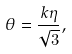<formula> <loc_0><loc_0><loc_500><loc_500>\theta = \frac { k \eta } { \sqrt { 3 } } ,</formula> 